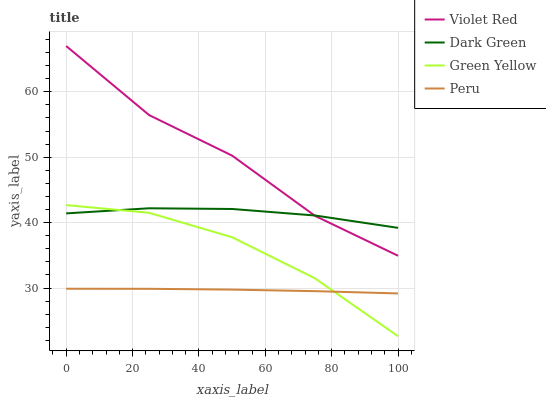Does Green Yellow have the minimum area under the curve?
Answer yes or no. No. Does Green Yellow have the maximum area under the curve?
Answer yes or no. No. Is Green Yellow the smoothest?
Answer yes or no. No. Is Green Yellow the roughest?
Answer yes or no. No. Does Peru have the lowest value?
Answer yes or no. No. Does Green Yellow have the highest value?
Answer yes or no. No. Is Peru less than Dark Green?
Answer yes or no. Yes. Is Violet Red greater than Green Yellow?
Answer yes or no. Yes. Does Peru intersect Dark Green?
Answer yes or no. No. 